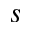Convert formula to latex. <formula><loc_0><loc_0><loc_500><loc_500>s</formula> 